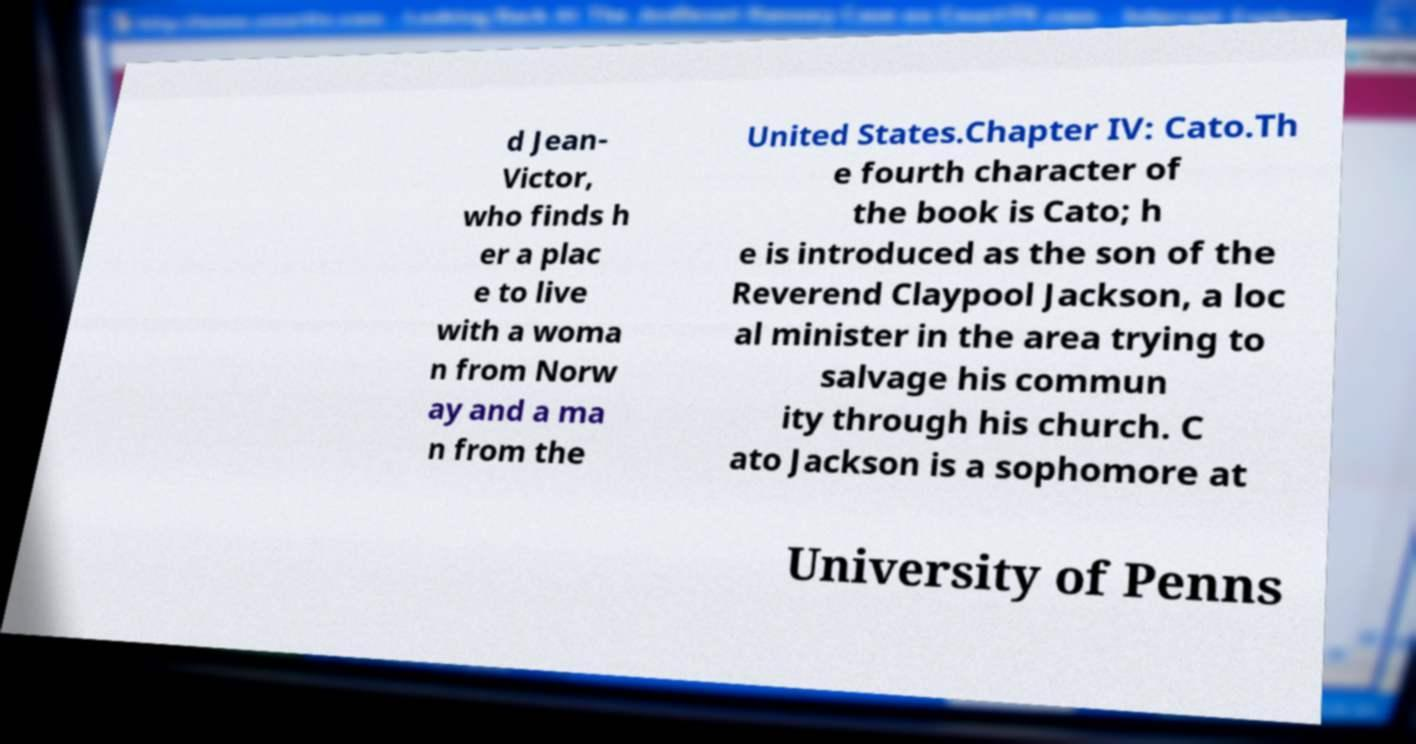I need the written content from this picture converted into text. Can you do that? d Jean- Victor, who finds h er a plac e to live with a woma n from Norw ay and a ma n from the United States.Chapter IV: Cato.Th e fourth character of the book is Cato; h e is introduced as the son of the Reverend Claypool Jackson, a loc al minister in the area trying to salvage his commun ity through his church. C ato Jackson is a sophomore at University of Penns 